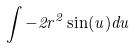Convert formula to latex. <formula><loc_0><loc_0><loc_500><loc_500>\int - 2 r ^ { 2 } \sin ( u ) d u</formula> 